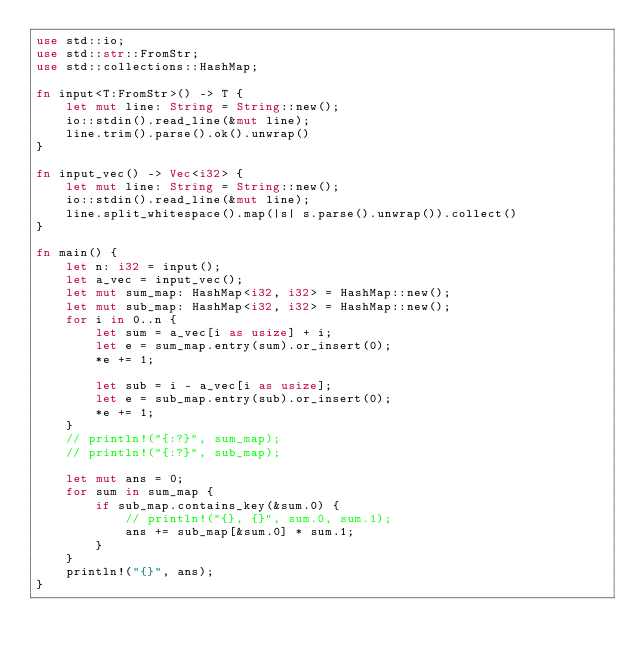Convert code to text. <code><loc_0><loc_0><loc_500><loc_500><_Rust_>use std::io;
use std::str::FromStr;
use std::collections::HashMap;

fn input<T:FromStr>() -> T {
    let mut line: String = String::new();
    io::stdin().read_line(&mut line);
    line.trim().parse().ok().unwrap()
}

fn input_vec() -> Vec<i32> {
    let mut line: String = String::new();
    io::stdin().read_line(&mut line);
    line.split_whitespace().map(|s| s.parse().unwrap()).collect()
}

fn main() {
    let n: i32 = input();
    let a_vec = input_vec();
    let mut sum_map: HashMap<i32, i32> = HashMap::new();
    let mut sub_map: HashMap<i32, i32> = HashMap::new();
    for i in 0..n {
        let sum = a_vec[i as usize] + i; 
        let e = sum_map.entry(sum).or_insert(0);
        *e += 1;

        let sub = i - a_vec[i as usize];
        let e = sub_map.entry(sub).or_insert(0);
        *e += 1;
    }
    // println!("{:?}", sum_map);
    // println!("{:?}", sub_map);

    let mut ans = 0;
    for sum in sum_map {
        if sub_map.contains_key(&sum.0) {
            // println!("{}, {}", sum.0, sum.1);
            ans += sub_map[&sum.0] * sum.1;
        }
    }
    println!("{}", ans);
}</code> 